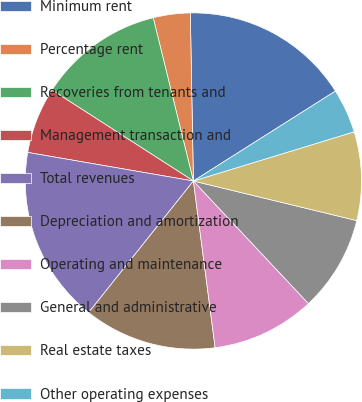Convert chart. <chart><loc_0><loc_0><loc_500><loc_500><pie_chart><fcel>Minimum rent<fcel>Percentage rent<fcel>Recoveries from tenants and<fcel>Management transaction and<fcel>Total revenues<fcel>Depreciation and amortization<fcel>Operating and maintenance<fcel>General and administrative<fcel>Real estate taxes<fcel>Other operating expenses<nl><fcel>16.31%<fcel>3.55%<fcel>12.06%<fcel>6.38%<fcel>17.02%<fcel>12.77%<fcel>9.93%<fcel>9.22%<fcel>8.51%<fcel>4.26%<nl></chart> 